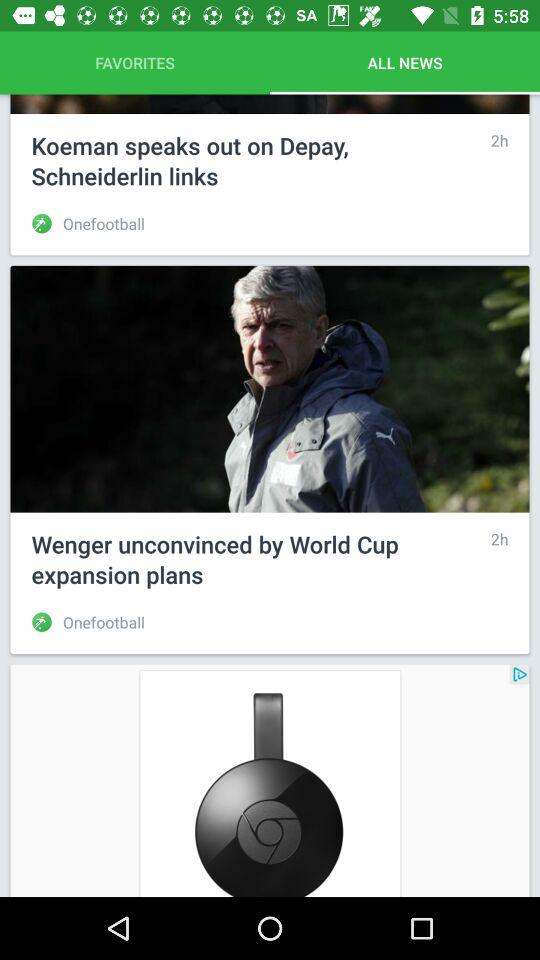How many hours ago had "Koeman speaks out on Depay" been posted? "Koeman speaks out on Depay" had been posted 2 hours ago. 